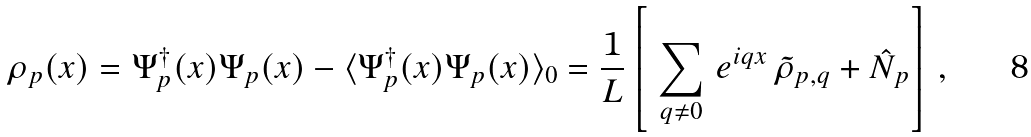<formula> <loc_0><loc_0><loc_500><loc_500>\rho _ { p } ( x ) = \Psi ^ { \dagger } _ { p } ( x ) \Psi _ { p } ( x ) - \langle \Psi ^ { \dagger } _ { p } ( x ) \Psi _ { p } ( x ) \rangle _ { 0 } = \frac { 1 } { L } \left [ \ \sum _ { q \neq 0 } \, e ^ { i q x } \, \tilde { \rho } _ { p , q } + \hat { N } _ { p } \right ] \, ,</formula> 